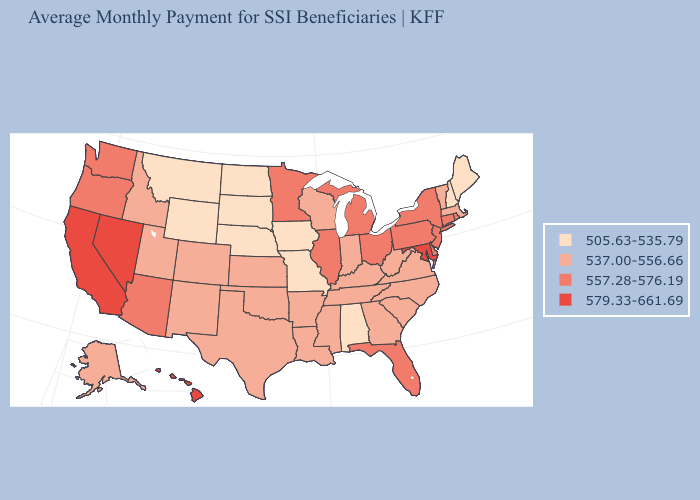What is the highest value in the West ?
Short answer required. 579.33-661.69. What is the highest value in the USA?
Be succinct. 579.33-661.69. Among the states that border Connecticut , which have the highest value?
Give a very brief answer. New York, Rhode Island. Does Illinois have the highest value in the MidWest?
Answer briefly. Yes. What is the value of North Dakota?
Be succinct. 505.63-535.79. How many symbols are there in the legend?
Answer briefly. 4. What is the value of Arizona?
Keep it brief. 557.28-576.19. Does New Mexico have a higher value than Georgia?
Short answer required. No. Among the states that border Ohio , which have the lowest value?
Write a very short answer. Indiana, Kentucky, West Virginia. Name the states that have a value in the range 579.33-661.69?
Give a very brief answer. California, Hawaii, Maryland, Nevada. What is the value of Rhode Island?
Keep it brief. 557.28-576.19. Among the states that border Wyoming , does Nebraska have the highest value?
Keep it brief. No. Name the states that have a value in the range 557.28-576.19?
Write a very short answer. Arizona, Connecticut, Delaware, Florida, Illinois, Michigan, Minnesota, New Jersey, New York, Ohio, Oregon, Pennsylvania, Rhode Island, Washington. Which states have the lowest value in the USA?
Write a very short answer. Alabama, Iowa, Maine, Missouri, Montana, Nebraska, New Hampshire, North Dakota, South Dakota, Wyoming. Name the states that have a value in the range 557.28-576.19?
Quick response, please. Arizona, Connecticut, Delaware, Florida, Illinois, Michigan, Minnesota, New Jersey, New York, Ohio, Oregon, Pennsylvania, Rhode Island, Washington. 